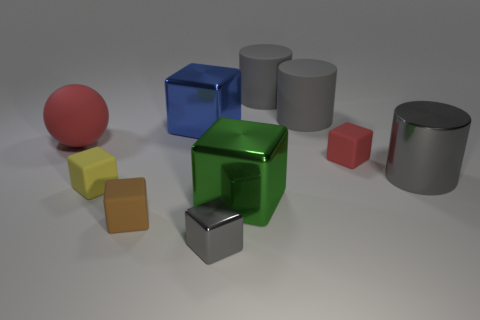What number of objects are either green cubes or large gray cylinders that are behind the big gray metallic thing?
Provide a short and direct response. 3. What color is the rubber thing that is both in front of the blue metallic object and right of the gray cube?
Provide a short and direct response. Red. Is the green object the same size as the red rubber block?
Ensure brevity in your answer.  No. What is the color of the large cylinder that is in front of the small red rubber thing?
Offer a very short reply. Gray. Are there any small rubber things of the same color as the small metallic cube?
Ensure brevity in your answer.  No. There is another metallic cube that is the same size as the green shiny block; what color is it?
Provide a short and direct response. Blue. Do the big red object and the small brown matte object have the same shape?
Ensure brevity in your answer.  No. What material is the tiny thing right of the small gray shiny object?
Keep it short and to the point. Rubber. What color is the sphere?
Offer a very short reply. Red. There is a gray metal object that is behind the big green thing; is its size the same as the red matte thing left of the tiny red matte thing?
Make the answer very short. Yes. 